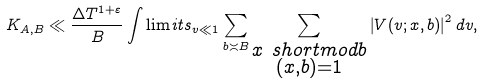<formula> <loc_0><loc_0><loc_500><loc_500>K _ { A , B } \ll \frac { \Delta T ^ { 1 + \varepsilon } } { B } \int \lim i t s _ { v \ll 1 } \sum _ { b \asymp B } \sum _ { \substack { x \ s h o r t m o d { b } \\ ( x , b ) = 1 } } \left | V ( v ; x , b ) \right | ^ { 2 } d v ,</formula> 